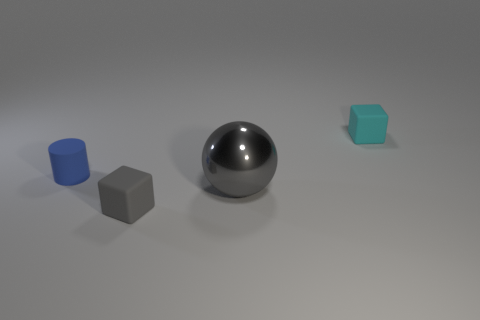There is a thing that is left of the cyan object and behind the large gray object; how big is it?
Offer a terse response. Small. Does the block right of the tiny gray matte object have the same color as the large sphere?
Keep it short and to the point. No. Are there fewer tiny cyan matte objects in front of the small cyan matte object than large metallic cubes?
Offer a terse response. No. There is a gray object that is the same material as the cyan object; what is its shape?
Provide a short and direct response. Cube. Does the gray block have the same material as the small cyan block?
Make the answer very short. Yes. Is the number of tiny cyan things that are left of the tiny cylinder less than the number of gray metal things in front of the large metallic sphere?
Provide a succinct answer. No. What size is the matte object that is the same color as the shiny object?
Your answer should be very brief. Small. How many tiny gray blocks are behind the tiny thing that is on the left side of the cube that is in front of the small cyan matte block?
Your answer should be very brief. 0. Is the metallic sphere the same color as the cylinder?
Give a very brief answer. No. Is there a small metal ball that has the same color as the metallic object?
Make the answer very short. No. 